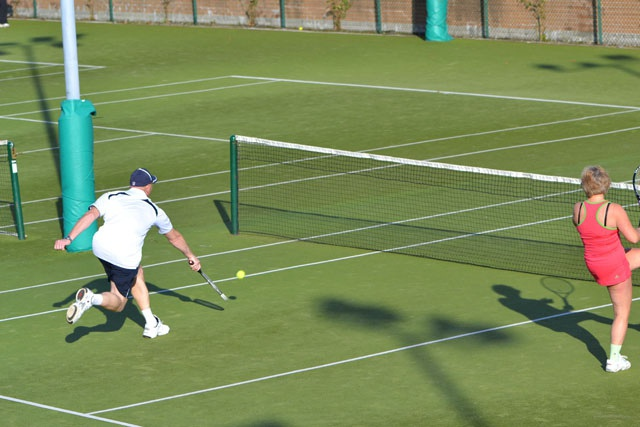Describe the objects in this image and their specific colors. I can see people in black, white, lightpink, gray, and navy tones, people in black, salmon, olive, and tan tones, tennis racket in black, gray, and darkgray tones, tennis racket in black, darkgray, gray, lightgray, and olive tones, and sports ball in black, khaki, and olive tones in this image. 